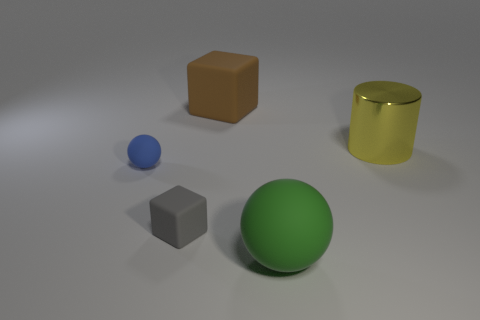Is the number of blue spheres that are to the right of the small blue rubber thing less than the number of tiny balls?
Your answer should be very brief. Yes. There is a large thing that is in front of the yellow object; what is its color?
Ensure brevity in your answer.  Green. There is a yellow cylinder that is behind the ball that is behind the large green matte object; what is it made of?
Provide a succinct answer. Metal. Is there a blue ball of the same size as the yellow thing?
Your answer should be very brief. No. What number of objects are either small objects on the right side of the blue thing or rubber cubes behind the yellow metal cylinder?
Your response must be concise. 2. There is a rubber object to the right of the big brown matte block; is its size the same as the matte block behind the small rubber ball?
Your answer should be compact. Yes. There is a large matte thing behind the large green ball; are there any big metal cylinders to the right of it?
Keep it short and to the point. Yes. There is a green sphere; what number of matte spheres are behind it?
Offer a terse response. 1. How many other objects are the same color as the big shiny thing?
Give a very brief answer. 0. Are there fewer spheres that are right of the large brown block than objects behind the green rubber object?
Offer a terse response. Yes. 